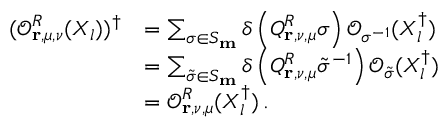<formula> <loc_0><loc_0><loc_500><loc_500>\begin{array} { r l } { ( \mathcal { O } _ { r , \mu , \nu } ^ { R } ( X _ { l } ) ) ^ { \dagger } } & { = \sum _ { \sigma \in S _ { m } } \delta \left ( Q _ { r , \nu , \mu } ^ { R } \sigma \right ) \mathcal { O } _ { \sigma ^ { - 1 } } ( X _ { l } ^ { \dagger } ) } \\ & { = \sum _ { \tilde { \sigma } \in S _ { m } } \delta \left ( Q _ { r , \nu , \mu } ^ { R } \tilde { \sigma } ^ { - 1 } \right ) \mathcal { O } _ { \tilde { \sigma } } ( X _ { l } ^ { \dagger } ) } \\ & { = \mathcal { O } _ { r , \nu , \mu } ^ { R } ( X _ { l } ^ { \dagger } ) \, . } \end{array}</formula> 